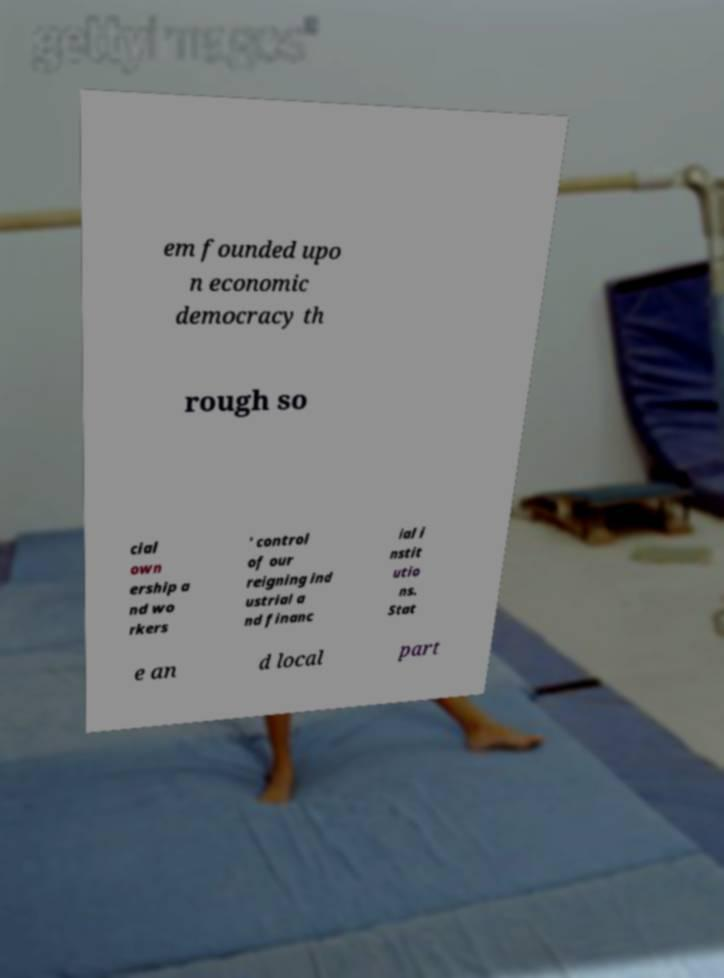Could you extract and type out the text from this image? em founded upo n economic democracy th rough so cial own ership a nd wo rkers ' control of our reigning ind ustrial a nd financ ial i nstit utio ns. Stat e an d local part 